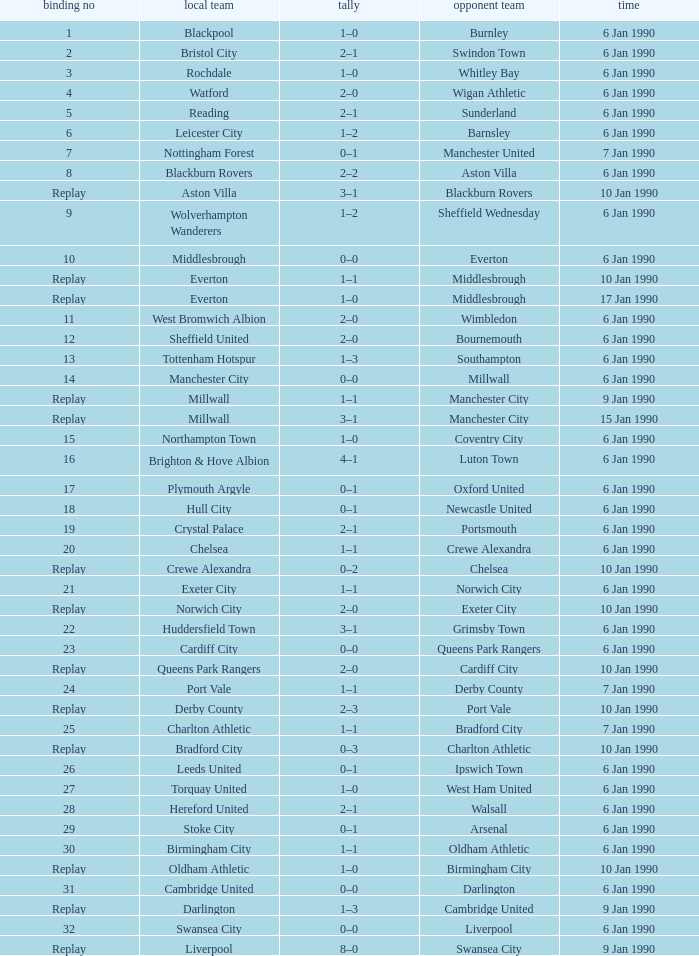What is the score of the game against away team exeter city on 10 jan 1990? 2–0. 